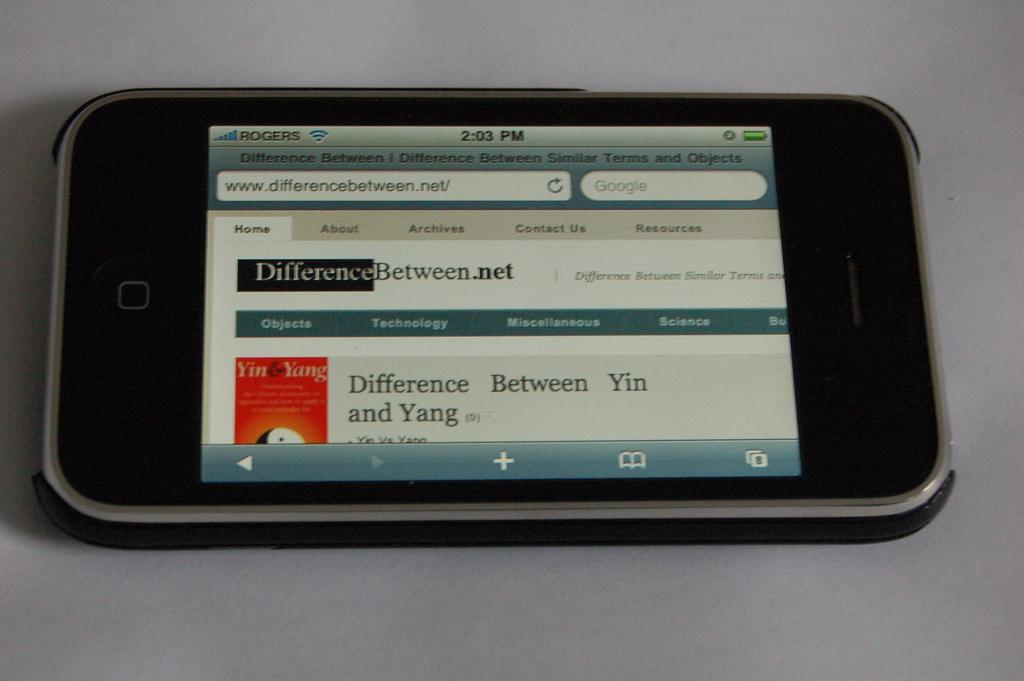What electronic device is present in the image? There is a mobile phone in the image. Where is the mobile phone located? The mobile phone is on a surface. What can be seen on the screen of the mobile phone? There is text visible on the mobile phone. What type of pump is visible in the image? There is no pump present in the image. Can you describe the skate on the surface where the mobile phone is located? The surface where the mobile phone is located is not described in enough detail to determine if it is suitable for skating. 